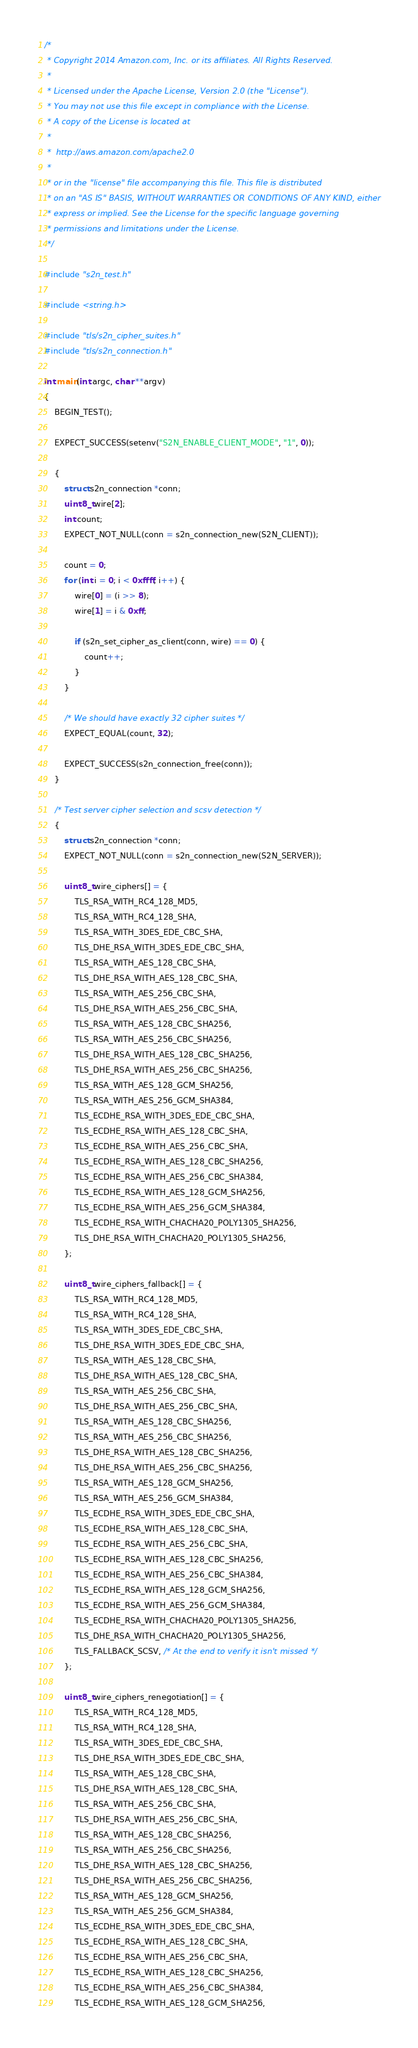Convert code to text. <code><loc_0><loc_0><loc_500><loc_500><_C_>/*
 * Copyright 2014 Amazon.com, Inc. or its affiliates. All Rights Reserved.
 *
 * Licensed under the Apache License, Version 2.0 (the "License").
 * You may not use this file except in compliance with the License.
 * A copy of the License is located at
 *
 *  http://aws.amazon.com/apache2.0
 *
 * or in the "license" file accompanying this file. This file is distributed
 * on an "AS IS" BASIS, WITHOUT WARRANTIES OR CONDITIONS OF ANY KIND, either
 * express or implied. See the License for the specific language governing
 * permissions and limitations under the License.
 */

#include "s2n_test.h"

#include <string.h>

#include "tls/s2n_cipher_suites.h"
#include "tls/s2n_connection.h"

int main(int argc, char **argv)
{
    BEGIN_TEST();

    EXPECT_SUCCESS(setenv("S2N_ENABLE_CLIENT_MODE", "1", 0));

    {
        struct s2n_connection *conn;
        uint8_t wire[2];
        int count;
        EXPECT_NOT_NULL(conn = s2n_connection_new(S2N_CLIENT));

        count = 0;
        for (int i = 0; i < 0xffff; i++) {
            wire[0] = (i >> 8);
            wire[1] = i & 0xff;

            if (s2n_set_cipher_as_client(conn, wire) == 0) {
                count++;
            }
        }

        /* We should have exactly 32 cipher suites */
        EXPECT_EQUAL(count, 32);

        EXPECT_SUCCESS(s2n_connection_free(conn));
    }

    /* Test server cipher selection and scsv detection */
    {
        struct s2n_connection *conn;
        EXPECT_NOT_NULL(conn = s2n_connection_new(S2N_SERVER));

        uint8_t wire_ciphers[] = {
            TLS_RSA_WITH_RC4_128_MD5,
            TLS_RSA_WITH_RC4_128_SHA,
            TLS_RSA_WITH_3DES_EDE_CBC_SHA,
            TLS_DHE_RSA_WITH_3DES_EDE_CBC_SHA,
            TLS_RSA_WITH_AES_128_CBC_SHA,
            TLS_DHE_RSA_WITH_AES_128_CBC_SHA,
            TLS_RSA_WITH_AES_256_CBC_SHA,
            TLS_DHE_RSA_WITH_AES_256_CBC_SHA,
            TLS_RSA_WITH_AES_128_CBC_SHA256,
            TLS_RSA_WITH_AES_256_CBC_SHA256,
            TLS_DHE_RSA_WITH_AES_128_CBC_SHA256,
            TLS_DHE_RSA_WITH_AES_256_CBC_SHA256,
            TLS_RSA_WITH_AES_128_GCM_SHA256,
            TLS_RSA_WITH_AES_256_GCM_SHA384,
            TLS_ECDHE_RSA_WITH_3DES_EDE_CBC_SHA,
            TLS_ECDHE_RSA_WITH_AES_128_CBC_SHA,
            TLS_ECDHE_RSA_WITH_AES_256_CBC_SHA,
            TLS_ECDHE_RSA_WITH_AES_128_CBC_SHA256,
            TLS_ECDHE_RSA_WITH_AES_256_CBC_SHA384,
            TLS_ECDHE_RSA_WITH_AES_128_GCM_SHA256,
            TLS_ECDHE_RSA_WITH_AES_256_GCM_SHA384,
            TLS_ECDHE_RSA_WITH_CHACHA20_POLY1305_SHA256,
            TLS_DHE_RSA_WITH_CHACHA20_POLY1305_SHA256,
        };

        uint8_t wire_ciphers_fallback[] = {
            TLS_RSA_WITH_RC4_128_MD5,
            TLS_RSA_WITH_RC4_128_SHA,
            TLS_RSA_WITH_3DES_EDE_CBC_SHA,
            TLS_DHE_RSA_WITH_3DES_EDE_CBC_SHA,
            TLS_RSA_WITH_AES_128_CBC_SHA,
            TLS_DHE_RSA_WITH_AES_128_CBC_SHA,
            TLS_RSA_WITH_AES_256_CBC_SHA,
            TLS_DHE_RSA_WITH_AES_256_CBC_SHA,
            TLS_RSA_WITH_AES_128_CBC_SHA256,
            TLS_RSA_WITH_AES_256_CBC_SHA256,
            TLS_DHE_RSA_WITH_AES_128_CBC_SHA256,
            TLS_DHE_RSA_WITH_AES_256_CBC_SHA256,
            TLS_RSA_WITH_AES_128_GCM_SHA256,
            TLS_RSA_WITH_AES_256_GCM_SHA384,
            TLS_ECDHE_RSA_WITH_3DES_EDE_CBC_SHA,
            TLS_ECDHE_RSA_WITH_AES_128_CBC_SHA,
            TLS_ECDHE_RSA_WITH_AES_256_CBC_SHA,
            TLS_ECDHE_RSA_WITH_AES_128_CBC_SHA256,
            TLS_ECDHE_RSA_WITH_AES_256_CBC_SHA384,
            TLS_ECDHE_RSA_WITH_AES_128_GCM_SHA256,
            TLS_ECDHE_RSA_WITH_AES_256_GCM_SHA384,
            TLS_ECDHE_RSA_WITH_CHACHA20_POLY1305_SHA256,
            TLS_DHE_RSA_WITH_CHACHA20_POLY1305_SHA256,
            TLS_FALLBACK_SCSV, /* At the end to verify it isn't missed */
        };

        uint8_t wire_ciphers_renegotiation[] = {
            TLS_RSA_WITH_RC4_128_MD5,
            TLS_RSA_WITH_RC4_128_SHA,
            TLS_RSA_WITH_3DES_EDE_CBC_SHA,
            TLS_DHE_RSA_WITH_3DES_EDE_CBC_SHA,
            TLS_RSA_WITH_AES_128_CBC_SHA,
            TLS_DHE_RSA_WITH_AES_128_CBC_SHA,
            TLS_RSA_WITH_AES_256_CBC_SHA,
            TLS_DHE_RSA_WITH_AES_256_CBC_SHA,
            TLS_RSA_WITH_AES_128_CBC_SHA256,
            TLS_RSA_WITH_AES_256_CBC_SHA256,
            TLS_DHE_RSA_WITH_AES_128_CBC_SHA256,
            TLS_DHE_RSA_WITH_AES_256_CBC_SHA256,
            TLS_RSA_WITH_AES_128_GCM_SHA256,
            TLS_RSA_WITH_AES_256_GCM_SHA384,
            TLS_ECDHE_RSA_WITH_3DES_EDE_CBC_SHA,
            TLS_ECDHE_RSA_WITH_AES_128_CBC_SHA,
            TLS_ECDHE_RSA_WITH_AES_256_CBC_SHA,
            TLS_ECDHE_RSA_WITH_AES_128_CBC_SHA256,
            TLS_ECDHE_RSA_WITH_AES_256_CBC_SHA384,
            TLS_ECDHE_RSA_WITH_AES_128_GCM_SHA256,</code> 